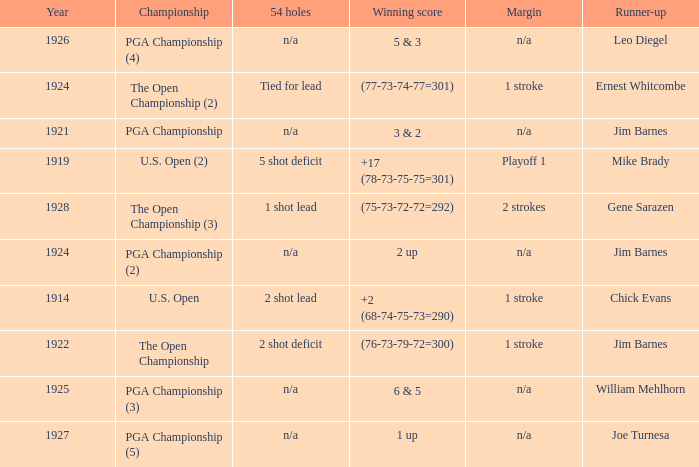In what number of years was the score achieved (76-73-79-72=300)? 1.0. 